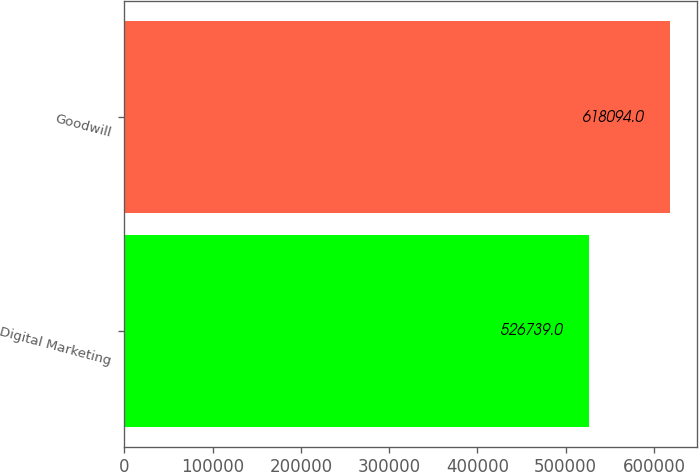Convert chart. <chart><loc_0><loc_0><loc_500><loc_500><bar_chart><fcel>Digital Marketing<fcel>Goodwill<nl><fcel>526739<fcel>618094<nl></chart> 